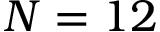<formula> <loc_0><loc_0><loc_500><loc_500>N = 1 2</formula> 